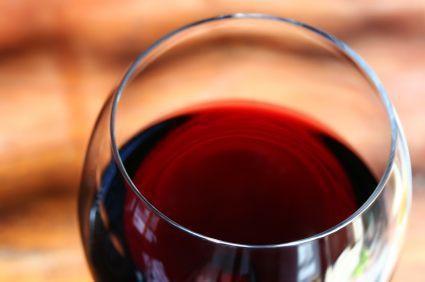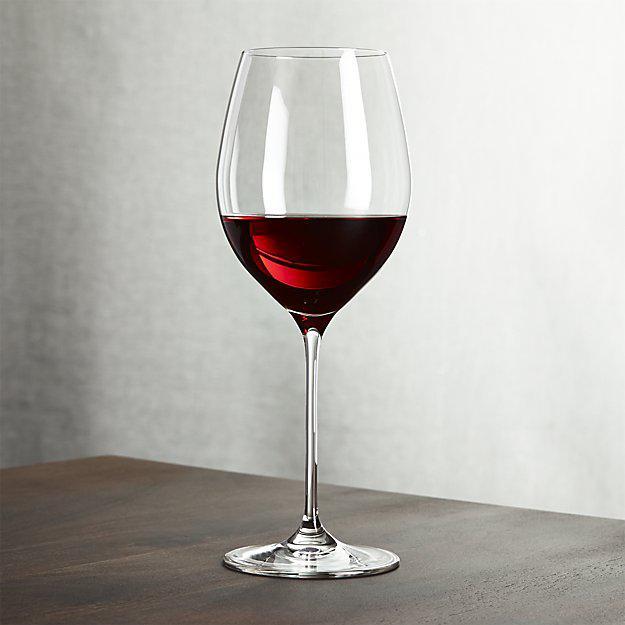The first image is the image on the left, the second image is the image on the right. Analyze the images presented: Is the assertion "The entire wine glass can be seen in one of the images." valid? Answer yes or no. Yes. 